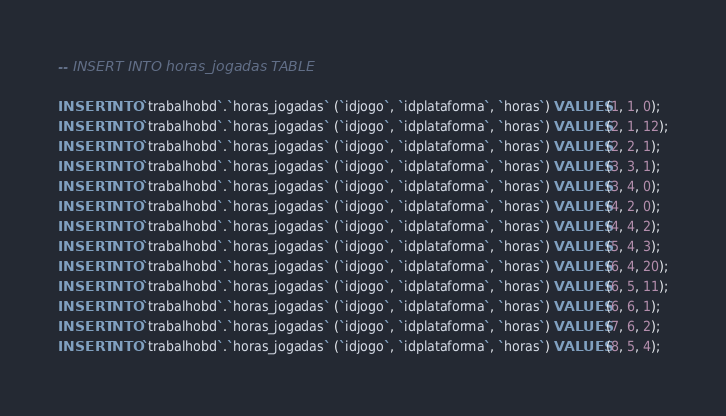Convert code to text. <code><loc_0><loc_0><loc_500><loc_500><_SQL_>-- INSERT INTO horas_jogadas TABLE

INSERT INTO `trabalhobd`.`horas_jogadas` (`idjogo`, `idplataforma`, `horas`) VALUES (1, 1, 0);
INSERT INTO `trabalhobd`.`horas_jogadas` (`idjogo`, `idplataforma`, `horas`) VALUES (2, 1, 12);
INSERT INTO `trabalhobd`.`horas_jogadas` (`idjogo`, `idplataforma`, `horas`) VALUES (2, 2, 1);
INSERT INTO `trabalhobd`.`horas_jogadas` (`idjogo`, `idplataforma`, `horas`) VALUES (3, 3, 1);
INSERT INTO `trabalhobd`.`horas_jogadas` (`idjogo`, `idplataforma`, `horas`) VALUES (3, 4, 0);
INSERT INTO `trabalhobd`.`horas_jogadas` (`idjogo`, `idplataforma`, `horas`) VALUES (4, 2, 0);
INSERT INTO `trabalhobd`.`horas_jogadas` (`idjogo`, `idplataforma`, `horas`) VALUES (4, 4, 2);
INSERT INTO `trabalhobd`.`horas_jogadas` (`idjogo`, `idplataforma`, `horas`) VALUES (5, 4, 3);
INSERT INTO `trabalhobd`.`horas_jogadas` (`idjogo`, `idplataforma`, `horas`) VALUES (6, 4, 20);
INSERT INTO `trabalhobd`.`horas_jogadas` (`idjogo`, `idplataforma`, `horas`) VALUES (6, 5, 11);
INSERT INTO `trabalhobd`.`horas_jogadas` (`idjogo`, `idplataforma`, `horas`) VALUES (6, 6, 1);
INSERT INTO `trabalhobd`.`horas_jogadas` (`idjogo`, `idplataforma`, `horas`) VALUES (7, 6, 2);
INSERT INTO `trabalhobd`.`horas_jogadas` (`idjogo`, `idplataforma`, `horas`) VALUES (8, 5, 4);</code> 